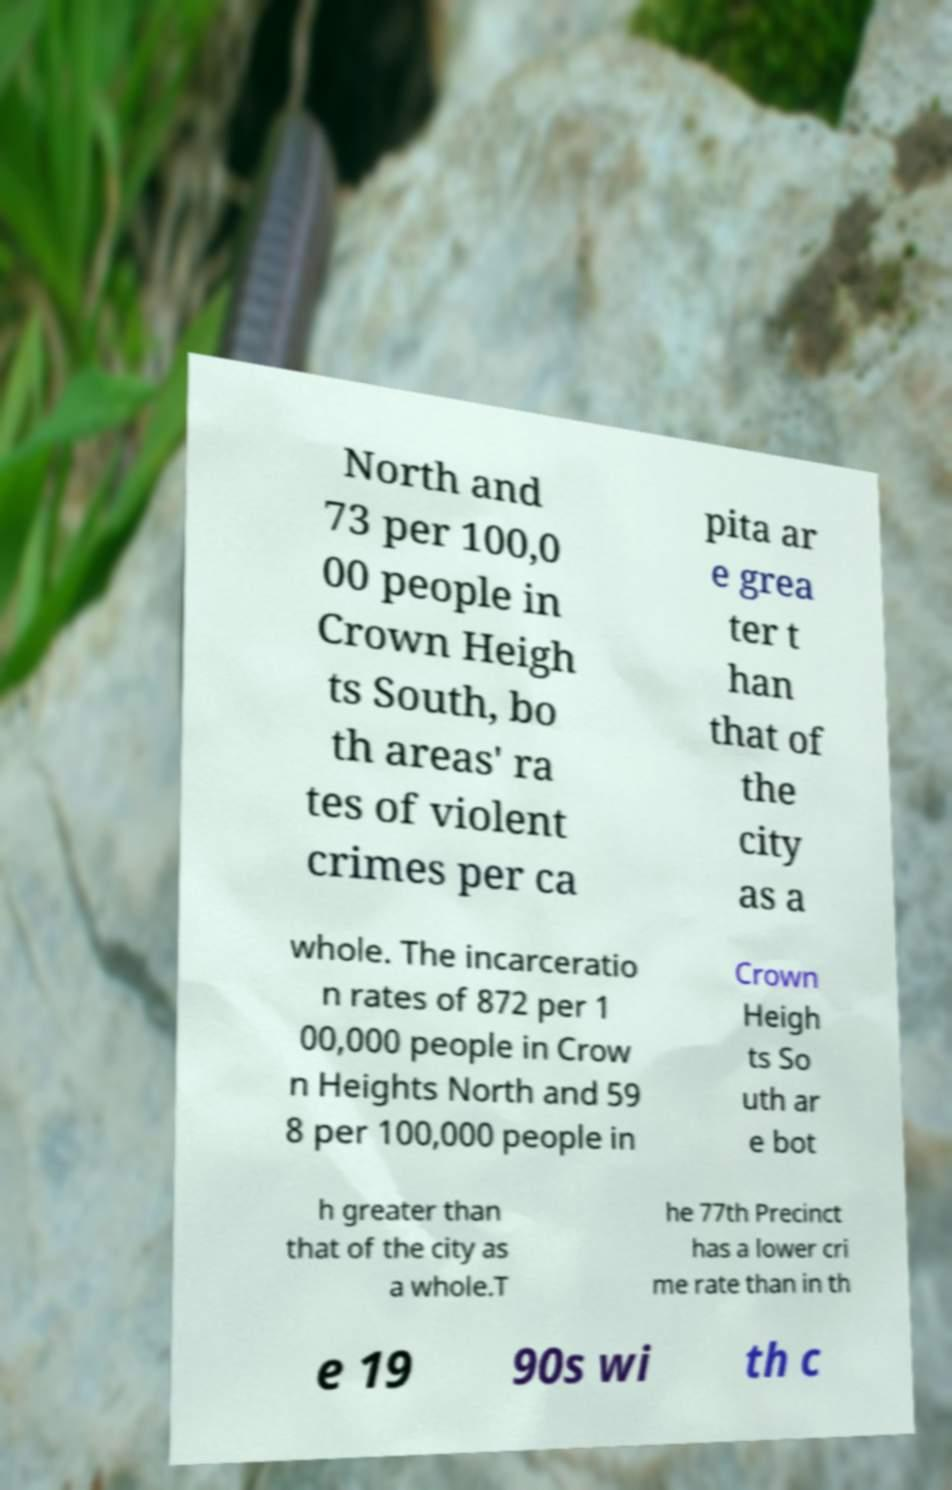Can you read and provide the text displayed in the image?This photo seems to have some interesting text. Can you extract and type it out for me? North and 73 per 100,0 00 people in Crown Heigh ts South, bo th areas' ra tes of violent crimes per ca pita ar e grea ter t han that of the city as a whole. The incarceratio n rates of 872 per 1 00,000 people in Crow n Heights North and 59 8 per 100,000 people in Crown Heigh ts So uth ar e bot h greater than that of the city as a whole.T he 77th Precinct has a lower cri me rate than in th e 19 90s wi th c 